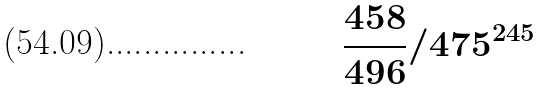Convert formula to latex. <formula><loc_0><loc_0><loc_500><loc_500>\frac { 4 5 8 } { 4 9 6 } / 4 7 5 ^ { 2 4 5 }</formula> 